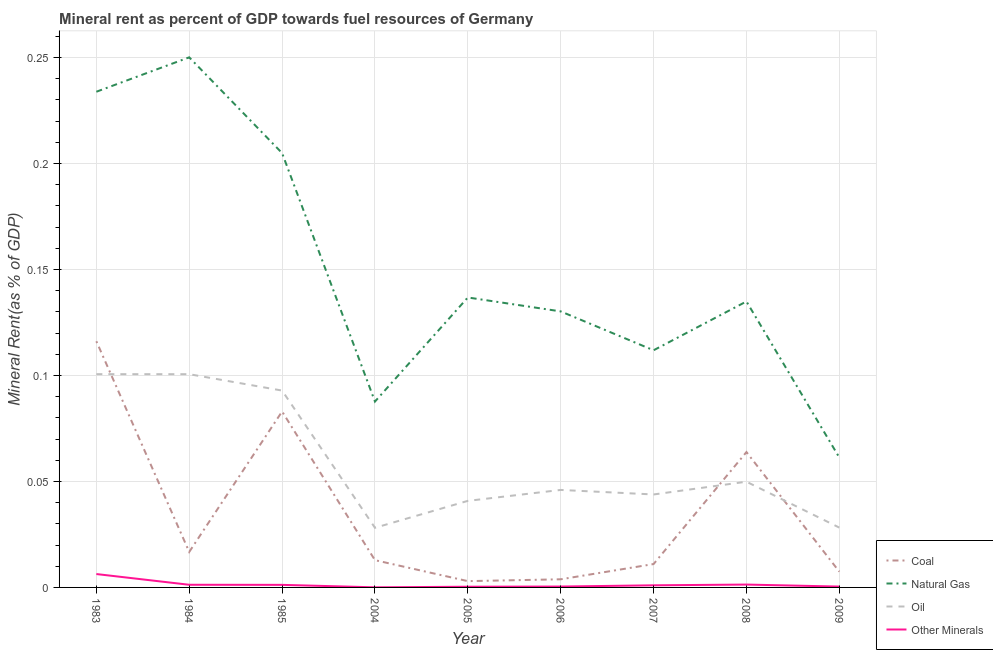Is the number of lines equal to the number of legend labels?
Your answer should be very brief. Yes. What is the oil rent in 1985?
Your response must be concise. 0.09. Across all years, what is the maximum coal rent?
Ensure brevity in your answer.  0.12. Across all years, what is the minimum coal rent?
Offer a terse response. 0. In which year was the oil rent minimum?
Make the answer very short. 2004. What is the total natural gas rent in the graph?
Provide a succinct answer. 1.35. What is the difference between the coal rent in 1985 and that in 2006?
Your answer should be compact. 0.08. What is the difference between the  rent of other minerals in 1985 and the natural gas rent in 2007?
Your response must be concise. -0.11. What is the average natural gas rent per year?
Give a very brief answer. 0.15. In the year 2006, what is the difference between the natural gas rent and oil rent?
Keep it short and to the point. 0.08. In how many years, is the  rent of other minerals greater than 0.24000000000000002 %?
Your answer should be very brief. 0. What is the ratio of the  rent of other minerals in 2008 to that in 2009?
Your answer should be very brief. 3.35. Is the difference between the oil rent in 1983 and 2008 greater than the difference between the  rent of other minerals in 1983 and 2008?
Give a very brief answer. Yes. What is the difference between the highest and the second highest coal rent?
Ensure brevity in your answer.  0.03. What is the difference between the highest and the lowest  rent of other minerals?
Your answer should be compact. 0.01. In how many years, is the oil rent greater than the average oil rent taken over all years?
Keep it short and to the point. 3. Is it the case that in every year, the sum of the coal rent and natural gas rent is greater than the oil rent?
Provide a succinct answer. Yes. Does the natural gas rent monotonically increase over the years?
Ensure brevity in your answer.  No. Is the  rent of other minerals strictly greater than the coal rent over the years?
Keep it short and to the point. No. Is the  rent of other minerals strictly less than the natural gas rent over the years?
Offer a terse response. Yes. How many lines are there?
Ensure brevity in your answer.  4. What is the difference between two consecutive major ticks on the Y-axis?
Offer a terse response. 0.05. Are the values on the major ticks of Y-axis written in scientific E-notation?
Offer a terse response. No. Does the graph contain any zero values?
Your response must be concise. No. Does the graph contain grids?
Ensure brevity in your answer.  Yes. How many legend labels are there?
Keep it short and to the point. 4. What is the title of the graph?
Keep it short and to the point. Mineral rent as percent of GDP towards fuel resources of Germany. Does "Public sector management" appear as one of the legend labels in the graph?
Offer a terse response. No. What is the label or title of the Y-axis?
Ensure brevity in your answer.  Mineral Rent(as % of GDP). What is the Mineral Rent(as % of GDP) in Coal in 1983?
Provide a succinct answer. 0.12. What is the Mineral Rent(as % of GDP) in Natural Gas in 1983?
Offer a very short reply. 0.23. What is the Mineral Rent(as % of GDP) of Oil in 1983?
Make the answer very short. 0.1. What is the Mineral Rent(as % of GDP) of Other Minerals in 1983?
Offer a very short reply. 0.01. What is the Mineral Rent(as % of GDP) of Coal in 1984?
Your response must be concise. 0.02. What is the Mineral Rent(as % of GDP) of Natural Gas in 1984?
Your answer should be very brief. 0.25. What is the Mineral Rent(as % of GDP) in Oil in 1984?
Offer a very short reply. 0.1. What is the Mineral Rent(as % of GDP) in Other Minerals in 1984?
Your answer should be very brief. 0. What is the Mineral Rent(as % of GDP) in Coal in 1985?
Keep it short and to the point. 0.08. What is the Mineral Rent(as % of GDP) in Natural Gas in 1985?
Give a very brief answer. 0.2. What is the Mineral Rent(as % of GDP) in Oil in 1985?
Provide a short and direct response. 0.09. What is the Mineral Rent(as % of GDP) in Other Minerals in 1985?
Your answer should be very brief. 0. What is the Mineral Rent(as % of GDP) of Coal in 2004?
Offer a terse response. 0.01. What is the Mineral Rent(as % of GDP) of Natural Gas in 2004?
Offer a terse response. 0.09. What is the Mineral Rent(as % of GDP) in Oil in 2004?
Give a very brief answer. 0.03. What is the Mineral Rent(as % of GDP) in Other Minerals in 2004?
Offer a terse response. 4.34617958129475e-5. What is the Mineral Rent(as % of GDP) in Coal in 2005?
Give a very brief answer. 0. What is the Mineral Rent(as % of GDP) of Natural Gas in 2005?
Your answer should be very brief. 0.14. What is the Mineral Rent(as % of GDP) of Oil in 2005?
Offer a very short reply. 0.04. What is the Mineral Rent(as % of GDP) of Other Minerals in 2005?
Provide a short and direct response. 0. What is the Mineral Rent(as % of GDP) of Coal in 2006?
Your response must be concise. 0. What is the Mineral Rent(as % of GDP) of Natural Gas in 2006?
Your response must be concise. 0.13. What is the Mineral Rent(as % of GDP) in Oil in 2006?
Offer a very short reply. 0.05. What is the Mineral Rent(as % of GDP) of Other Minerals in 2006?
Make the answer very short. 0. What is the Mineral Rent(as % of GDP) in Coal in 2007?
Keep it short and to the point. 0.01. What is the Mineral Rent(as % of GDP) in Natural Gas in 2007?
Your response must be concise. 0.11. What is the Mineral Rent(as % of GDP) in Oil in 2007?
Your response must be concise. 0.04. What is the Mineral Rent(as % of GDP) in Other Minerals in 2007?
Offer a terse response. 0. What is the Mineral Rent(as % of GDP) of Coal in 2008?
Provide a short and direct response. 0.06. What is the Mineral Rent(as % of GDP) of Natural Gas in 2008?
Your answer should be very brief. 0.13. What is the Mineral Rent(as % of GDP) in Oil in 2008?
Provide a short and direct response. 0.05. What is the Mineral Rent(as % of GDP) in Other Minerals in 2008?
Your answer should be very brief. 0. What is the Mineral Rent(as % of GDP) in Coal in 2009?
Ensure brevity in your answer.  0.01. What is the Mineral Rent(as % of GDP) in Natural Gas in 2009?
Your answer should be compact. 0.06. What is the Mineral Rent(as % of GDP) of Oil in 2009?
Your answer should be compact. 0.03. What is the Mineral Rent(as % of GDP) in Other Minerals in 2009?
Your response must be concise. 0. Across all years, what is the maximum Mineral Rent(as % of GDP) in Coal?
Your answer should be very brief. 0.12. Across all years, what is the maximum Mineral Rent(as % of GDP) in Natural Gas?
Your response must be concise. 0.25. Across all years, what is the maximum Mineral Rent(as % of GDP) of Oil?
Your response must be concise. 0.1. Across all years, what is the maximum Mineral Rent(as % of GDP) in Other Minerals?
Your answer should be compact. 0.01. Across all years, what is the minimum Mineral Rent(as % of GDP) in Coal?
Your response must be concise. 0. Across all years, what is the minimum Mineral Rent(as % of GDP) in Natural Gas?
Offer a terse response. 0.06. Across all years, what is the minimum Mineral Rent(as % of GDP) in Oil?
Your response must be concise. 0.03. Across all years, what is the minimum Mineral Rent(as % of GDP) of Other Minerals?
Your response must be concise. 4.34617958129475e-5. What is the total Mineral Rent(as % of GDP) of Coal in the graph?
Make the answer very short. 0.32. What is the total Mineral Rent(as % of GDP) of Natural Gas in the graph?
Provide a succinct answer. 1.35. What is the total Mineral Rent(as % of GDP) of Oil in the graph?
Your answer should be compact. 0.53. What is the total Mineral Rent(as % of GDP) of Other Minerals in the graph?
Give a very brief answer. 0.01. What is the difference between the Mineral Rent(as % of GDP) in Coal in 1983 and that in 1984?
Make the answer very short. 0.1. What is the difference between the Mineral Rent(as % of GDP) of Natural Gas in 1983 and that in 1984?
Offer a terse response. -0.02. What is the difference between the Mineral Rent(as % of GDP) of Oil in 1983 and that in 1984?
Keep it short and to the point. 0. What is the difference between the Mineral Rent(as % of GDP) of Other Minerals in 1983 and that in 1984?
Your response must be concise. 0.01. What is the difference between the Mineral Rent(as % of GDP) of Coal in 1983 and that in 1985?
Provide a succinct answer. 0.03. What is the difference between the Mineral Rent(as % of GDP) in Natural Gas in 1983 and that in 1985?
Keep it short and to the point. 0.03. What is the difference between the Mineral Rent(as % of GDP) in Oil in 1983 and that in 1985?
Ensure brevity in your answer.  0.01. What is the difference between the Mineral Rent(as % of GDP) of Other Minerals in 1983 and that in 1985?
Offer a very short reply. 0.01. What is the difference between the Mineral Rent(as % of GDP) in Coal in 1983 and that in 2004?
Your answer should be compact. 0.1. What is the difference between the Mineral Rent(as % of GDP) in Natural Gas in 1983 and that in 2004?
Your answer should be very brief. 0.15. What is the difference between the Mineral Rent(as % of GDP) of Oil in 1983 and that in 2004?
Give a very brief answer. 0.07. What is the difference between the Mineral Rent(as % of GDP) in Other Minerals in 1983 and that in 2004?
Keep it short and to the point. 0.01. What is the difference between the Mineral Rent(as % of GDP) in Coal in 1983 and that in 2005?
Provide a short and direct response. 0.11. What is the difference between the Mineral Rent(as % of GDP) of Natural Gas in 1983 and that in 2005?
Ensure brevity in your answer.  0.1. What is the difference between the Mineral Rent(as % of GDP) of Oil in 1983 and that in 2005?
Your response must be concise. 0.06. What is the difference between the Mineral Rent(as % of GDP) of Other Minerals in 1983 and that in 2005?
Provide a short and direct response. 0.01. What is the difference between the Mineral Rent(as % of GDP) of Coal in 1983 and that in 2006?
Keep it short and to the point. 0.11. What is the difference between the Mineral Rent(as % of GDP) in Natural Gas in 1983 and that in 2006?
Offer a very short reply. 0.1. What is the difference between the Mineral Rent(as % of GDP) of Oil in 1983 and that in 2006?
Offer a terse response. 0.05. What is the difference between the Mineral Rent(as % of GDP) of Other Minerals in 1983 and that in 2006?
Your answer should be very brief. 0.01. What is the difference between the Mineral Rent(as % of GDP) of Coal in 1983 and that in 2007?
Offer a very short reply. 0.11. What is the difference between the Mineral Rent(as % of GDP) in Natural Gas in 1983 and that in 2007?
Ensure brevity in your answer.  0.12. What is the difference between the Mineral Rent(as % of GDP) in Oil in 1983 and that in 2007?
Make the answer very short. 0.06. What is the difference between the Mineral Rent(as % of GDP) of Other Minerals in 1983 and that in 2007?
Give a very brief answer. 0.01. What is the difference between the Mineral Rent(as % of GDP) of Coal in 1983 and that in 2008?
Your response must be concise. 0.05. What is the difference between the Mineral Rent(as % of GDP) in Natural Gas in 1983 and that in 2008?
Make the answer very short. 0.1. What is the difference between the Mineral Rent(as % of GDP) of Oil in 1983 and that in 2008?
Offer a terse response. 0.05. What is the difference between the Mineral Rent(as % of GDP) of Other Minerals in 1983 and that in 2008?
Your answer should be compact. 0.01. What is the difference between the Mineral Rent(as % of GDP) in Coal in 1983 and that in 2009?
Your answer should be very brief. 0.11. What is the difference between the Mineral Rent(as % of GDP) of Natural Gas in 1983 and that in 2009?
Provide a short and direct response. 0.17. What is the difference between the Mineral Rent(as % of GDP) of Oil in 1983 and that in 2009?
Provide a short and direct response. 0.07. What is the difference between the Mineral Rent(as % of GDP) of Other Minerals in 1983 and that in 2009?
Offer a very short reply. 0.01. What is the difference between the Mineral Rent(as % of GDP) of Coal in 1984 and that in 1985?
Your answer should be very brief. -0.07. What is the difference between the Mineral Rent(as % of GDP) in Natural Gas in 1984 and that in 1985?
Offer a very short reply. 0.05. What is the difference between the Mineral Rent(as % of GDP) in Oil in 1984 and that in 1985?
Keep it short and to the point. 0.01. What is the difference between the Mineral Rent(as % of GDP) in Coal in 1984 and that in 2004?
Your answer should be very brief. 0. What is the difference between the Mineral Rent(as % of GDP) of Natural Gas in 1984 and that in 2004?
Your response must be concise. 0.16. What is the difference between the Mineral Rent(as % of GDP) of Oil in 1984 and that in 2004?
Make the answer very short. 0.07. What is the difference between the Mineral Rent(as % of GDP) in Other Minerals in 1984 and that in 2004?
Give a very brief answer. 0. What is the difference between the Mineral Rent(as % of GDP) of Coal in 1984 and that in 2005?
Your answer should be very brief. 0.01. What is the difference between the Mineral Rent(as % of GDP) in Natural Gas in 1984 and that in 2005?
Your answer should be compact. 0.11. What is the difference between the Mineral Rent(as % of GDP) in Oil in 1984 and that in 2005?
Provide a succinct answer. 0.06. What is the difference between the Mineral Rent(as % of GDP) of Other Minerals in 1984 and that in 2005?
Your answer should be compact. 0. What is the difference between the Mineral Rent(as % of GDP) in Coal in 1984 and that in 2006?
Ensure brevity in your answer.  0.01. What is the difference between the Mineral Rent(as % of GDP) in Natural Gas in 1984 and that in 2006?
Give a very brief answer. 0.12. What is the difference between the Mineral Rent(as % of GDP) in Oil in 1984 and that in 2006?
Your answer should be compact. 0.05. What is the difference between the Mineral Rent(as % of GDP) in Other Minerals in 1984 and that in 2006?
Your response must be concise. 0. What is the difference between the Mineral Rent(as % of GDP) in Coal in 1984 and that in 2007?
Keep it short and to the point. 0.01. What is the difference between the Mineral Rent(as % of GDP) of Natural Gas in 1984 and that in 2007?
Provide a succinct answer. 0.14. What is the difference between the Mineral Rent(as % of GDP) of Oil in 1984 and that in 2007?
Offer a terse response. 0.06. What is the difference between the Mineral Rent(as % of GDP) of Coal in 1984 and that in 2008?
Provide a succinct answer. -0.05. What is the difference between the Mineral Rent(as % of GDP) in Natural Gas in 1984 and that in 2008?
Offer a very short reply. 0.12. What is the difference between the Mineral Rent(as % of GDP) in Oil in 1984 and that in 2008?
Keep it short and to the point. 0.05. What is the difference between the Mineral Rent(as % of GDP) in Other Minerals in 1984 and that in 2008?
Provide a succinct answer. -0. What is the difference between the Mineral Rent(as % of GDP) in Coal in 1984 and that in 2009?
Give a very brief answer. 0.01. What is the difference between the Mineral Rent(as % of GDP) of Natural Gas in 1984 and that in 2009?
Your answer should be very brief. 0.19. What is the difference between the Mineral Rent(as % of GDP) in Oil in 1984 and that in 2009?
Ensure brevity in your answer.  0.07. What is the difference between the Mineral Rent(as % of GDP) of Other Minerals in 1984 and that in 2009?
Ensure brevity in your answer.  0. What is the difference between the Mineral Rent(as % of GDP) in Coal in 1985 and that in 2004?
Ensure brevity in your answer.  0.07. What is the difference between the Mineral Rent(as % of GDP) in Natural Gas in 1985 and that in 2004?
Keep it short and to the point. 0.12. What is the difference between the Mineral Rent(as % of GDP) of Oil in 1985 and that in 2004?
Provide a succinct answer. 0.06. What is the difference between the Mineral Rent(as % of GDP) of Other Minerals in 1985 and that in 2004?
Offer a very short reply. 0. What is the difference between the Mineral Rent(as % of GDP) of Natural Gas in 1985 and that in 2005?
Give a very brief answer. 0.07. What is the difference between the Mineral Rent(as % of GDP) in Oil in 1985 and that in 2005?
Keep it short and to the point. 0.05. What is the difference between the Mineral Rent(as % of GDP) of Other Minerals in 1985 and that in 2005?
Give a very brief answer. 0. What is the difference between the Mineral Rent(as % of GDP) in Coal in 1985 and that in 2006?
Provide a succinct answer. 0.08. What is the difference between the Mineral Rent(as % of GDP) in Natural Gas in 1985 and that in 2006?
Provide a succinct answer. 0.07. What is the difference between the Mineral Rent(as % of GDP) of Oil in 1985 and that in 2006?
Keep it short and to the point. 0.05. What is the difference between the Mineral Rent(as % of GDP) in Other Minerals in 1985 and that in 2006?
Your answer should be compact. 0. What is the difference between the Mineral Rent(as % of GDP) of Coal in 1985 and that in 2007?
Ensure brevity in your answer.  0.07. What is the difference between the Mineral Rent(as % of GDP) in Natural Gas in 1985 and that in 2007?
Provide a short and direct response. 0.09. What is the difference between the Mineral Rent(as % of GDP) in Oil in 1985 and that in 2007?
Ensure brevity in your answer.  0.05. What is the difference between the Mineral Rent(as % of GDP) in Other Minerals in 1985 and that in 2007?
Provide a succinct answer. 0. What is the difference between the Mineral Rent(as % of GDP) in Coal in 1985 and that in 2008?
Your answer should be compact. 0.02. What is the difference between the Mineral Rent(as % of GDP) of Natural Gas in 1985 and that in 2008?
Your answer should be compact. 0.07. What is the difference between the Mineral Rent(as % of GDP) in Oil in 1985 and that in 2008?
Provide a succinct answer. 0.04. What is the difference between the Mineral Rent(as % of GDP) in Other Minerals in 1985 and that in 2008?
Ensure brevity in your answer.  -0. What is the difference between the Mineral Rent(as % of GDP) in Coal in 1985 and that in 2009?
Make the answer very short. 0.08. What is the difference between the Mineral Rent(as % of GDP) in Natural Gas in 1985 and that in 2009?
Your answer should be very brief. 0.14. What is the difference between the Mineral Rent(as % of GDP) in Oil in 1985 and that in 2009?
Provide a short and direct response. 0.06. What is the difference between the Mineral Rent(as % of GDP) of Other Minerals in 1985 and that in 2009?
Your answer should be compact. 0. What is the difference between the Mineral Rent(as % of GDP) of Coal in 2004 and that in 2005?
Provide a succinct answer. 0.01. What is the difference between the Mineral Rent(as % of GDP) of Natural Gas in 2004 and that in 2005?
Keep it short and to the point. -0.05. What is the difference between the Mineral Rent(as % of GDP) in Oil in 2004 and that in 2005?
Offer a terse response. -0.01. What is the difference between the Mineral Rent(as % of GDP) of Other Minerals in 2004 and that in 2005?
Give a very brief answer. -0. What is the difference between the Mineral Rent(as % of GDP) of Coal in 2004 and that in 2006?
Provide a short and direct response. 0.01. What is the difference between the Mineral Rent(as % of GDP) in Natural Gas in 2004 and that in 2006?
Your response must be concise. -0.04. What is the difference between the Mineral Rent(as % of GDP) of Oil in 2004 and that in 2006?
Give a very brief answer. -0.02. What is the difference between the Mineral Rent(as % of GDP) in Other Minerals in 2004 and that in 2006?
Give a very brief answer. -0. What is the difference between the Mineral Rent(as % of GDP) in Coal in 2004 and that in 2007?
Keep it short and to the point. 0. What is the difference between the Mineral Rent(as % of GDP) of Natural Gas in 2004 and that in 2007?
Make the answer very short. -0.02. What is the difference between the Mineral Rent(as % of GDP) in Oil in 2004 and that in 2007?
Your answer should be very brief. -0.02. What is the difference between the Mineral Rent(as % of GDP) of Other Minerals in 2004 and that in 2007?
Offer a terse response. -0. What is the difference between the Mineral Rent(as % of GDP) of Coal in 2004 and that in 2008?
Provide a short and direct response. -0.05. What is the difference between the Mineral Rent(as % of GDP) of Natural Gas in 2004 and that in 2008?
Offer a very short reply. -0.05. What is the difference between the Mineral Rent(as % of GDP) in Oil in 2004 and that in 2008?
Your response must be concise. -0.02. What is the difference between the Mineral Rent(as % of GDP) in Other Minerals in 2004 and that in 2008?
Ensure brevity in your answer.  -0. What is the difference between the Mineral Rent(as % of GDP) of Coal in 2004 and that in 2009?
Ensure brevity in your answer.  0.01. What is the difference between the Mineral Rent(as % of GDP) of Natural Gas in 2004 and that in 2009?
Ensure brevity in your answer.  0.03. What is the difference between the Mineral Rent(as % of GDP) in Oil in 2004 and that in 2009?
Keep it short and to the point. -0. What is the difference between the Mineral Rent(as % of GDP) in Other Minerals in 2004 and that in 2009?
Make the answer very short. -0. What is the difference between the Mineral Rent(as % of GDP) of Coal in 2005 and that in 2006?
Provide a short and direct response. -0. What is the difference between the Mineral Rent(as % of GDP) in Natural Gas in 2005 and that in 2006?
Your response must be concise. 0.01. What is the difference between the Mineral Rent(as % of GDP) of Oil in 2005 and that in 2006?
Provide a succinct answer. -0.01. What is the difference between the Mineral Rent(as % of GDP) of Other Minerals in 2005 and that in 2006?
Your answer should be very brief. -0. What is the difference between the Mineral Rent(as % of GDP) of Coal in 2005 and that in 2007?
Your response must be concise. -0.01. What is the difference between the Mineral Rent(as % of GDP) in Natural Gas in 2005 and that in 2007?
Keep it short and to the point. 0.02. What is the difference between the Mineral Rent(as % of GDP) in Oil in 2005 and that in 2007?
Your answer should be compact. -0. What is the difference between the Mineral Rent(as % of GDP) of Other Minerals in 2005 and that in 2007?
Your response must be concise. -0. What is the difference between the Mineral Rent(as % of GDP) in Coal in 2005 and that in 2008?
Make the answer very short. -0.06. What is the difference between the Mineral Rent(as % of GDP) of Natural Gas in 2005 and that in 2008?
Offer a very short reply. 0. What is the difference between the Mineral Rent(as % of GDP) in Oil in 2005 and that in 2008?
Provide a short and direct response. -0.01. What is the difference between the Mineral Rent(as % of GDP) in Other Minerals in 2005 and that in 2008?
Your answer should be very brief. -0. What is the difference between the Mineral Rent(as % of GDP) in Coal in 2005 and that in 2009?
Your response must be concise. -0. What is the difference between the Mineral Rent(as % of GDP) in Natural Gas in 2005 and that in 2009?
Make the answer very short. 0.08. What is the difference between the Mineral Rent(as % of GDP) of Oil in 2005 and that in 2009?
Ensure brevity in your answer.  0.01. What is the difference between the Mineral Rent(as % of GDP) in Other Minerals in 2005 and that in 2009?
Offer a terse response. -0. What is the difference between the Mineral Rent(as % of GDP) of Coal in 2006 and that in 2007?
Offer a very short reply. -0.01. What is the difference between the Mineral Rent(as % of GDP) of Natural Gas in 2006 and that in 2007?
Provide a succinct answer. 0.02. What is the difference between the Mineral Rent(as % of GDP) of Oil in 2006 and that in 2007?
Offer a terse response. 0. What is the difference between the Mineral Rent(as % of GDP) of Other Minerals in 2006 and that in 2007?
Make the answer very short. -0. What is the difference between the Mineral Rent(as % of GDP) in Coal in 2006 and that in 2008?
Your response must be concise. -0.06. What is the difference between the Mineral Rent(as % of GDP) of Natural Gas in 2006 and that in 2008?
Provide a succinct answer. -0. What is the difference between the Mineral Rent(as % of GDP) in Oil in 2006 and that in 2008?
Your answer should be very brief. -0. What is the difference between the Mineral Rent(as % of GDP) of Other Minerals in 2006 and that in 2008?
Your answer should be very brief. -0. What is the difference between the Mineral Rent(as % of GDP) of Coal in 2006 and that in 2009?
Provide a short and direct response. -0. What is the difference between the Mineral Rent(as % of GDP) of Natural Gas in 2006 and that in 2009?
Offer a terse response. 0.07. What is the difference between the Mineral Rent(as % of GDP) in Oil in 2006 and that in 2009?
Offer a terse response. 0.02. What is the difference between the Mineral Rent(as % of GDP) of Coal in 2007 and that in 2008?
Offer a very short reply. -0.05. What is the difference between the Mineral Rent(as % of GDP) of Natural Gas in 2007 and that in 2008?
Offer a terse response. -0.02. What is the difference between the Mineral Rent(as % of GDP) of Oil in 2007 and that in 2008?
Your answer should be compact. -0.01. What is the difference between the Mineral Rent(as % of GDP) in Other Minerals in 2007 and that in 2008?
Ensure brevity in your answer.  -0. What is the difference between the Mineral Rent(as % of GDP) in Coal in 2007 and that in 2009?
Provide a succinct answer. 0. What is the difference between the Mineral Rent(as % of GDP) in Natural Gas in 2007 and that in 2009?
Ensure brevity in your answer.  0.05. What is the difference between the Mineral Rent(as % of GDP) of Oil in 2007 and that in 2009?
Your answer should be compact. 0.02. What is the difference between the Mineral Rent(as % of GDP) of Other Minerals in 2007 and that in 2009?
Offer a very short reply. 0. What is the difference between the Mineral Rent(as % of GDP) in Coal in 2008 and that in 2009?
Offer a very short reply. 0.06. What is the difference between the Mineral Rent(as % of GDP) in Natural Gas in 2008 and that in 2009?
Provide a short and direct response. 0.07. What is the difference between the Mineral Rent(as % of GDP) in Oil in 2008 and that in 2009?
Offer a terse response. 0.02. What is the difference between the Mineral Rent(as % of GDP) of Other Minerals in 2008 and that in 2009?
Offer a very short reply. 0. What is the difference between the Mineral Rent(as % of GDP) in Coal in 1983 and the Mineral Rent(as % of GDP) in Natural Gas in 1984?
Provide a succinct answer. -0.13. What is the difference between the Mineral Rent(as % of GDP) in Coal in 1983 and the Mineral Rent(as % of GDP) in Oil in 1984?
Offer a terse response. 0.02. What is the difference between the Mineral Rent(as % of GDP) of Coal in 1983 and the Mineral Rent(as % of GDP) of Other Minerals in 1984?
Ensure brevity in your answer.  0.11. What is the difference between the Mineral Rent(as % of GDP) in Natural Gas in 1983 and the Mineral Rent(as % of GDP) in Oil in 1984?
Your answer should be compact. 0.13. What is the difference between the Mineral Rent(as % of GDP) in Natural Gas in 1983 and the Mineral Rent(as % of GDP) in Other Minerals in 1984?
Make the answer very short. 0.23. What is the difference between the Mineral Rent(as % of GDP) in Oil in 1983 and the Mineral Rent(as % of GDP) in Other Minerals in 1984?
Offer a terse response. 0.1. What is the difference between the Mineral Rent(as % of GDP) of Coal in 1983 and the Mineral Rent(as % of GDP) of Natural Gas in 1985?
Your response must be concise. -0.09. What is the difference between the Mineral Rent(as % of GDP) of Coal in 1983 and the Mineral Rent(as % of GDP) of Oil in 1985?
Your answer should be compact. 0.02. What is the difference between the Mineral Rent(as % of GDP) of Coal in 1983 and the Mineral Rent(as % of GDP) of Other Minerals in 1985?
Keep it short and to the point. 0.11. What is the difference between the Mineral Rent(as % of GDP) in Natural Gas in 1983 and the Mineral Rent(as % of GDP) in Oil in 1985?
Offer a terse response. 0.14. What is the difference between the Mineral Rent(as % of GDP) of Natural Gas in 1983 and the Mineral Rent(as % of GDP) of Other Minerals in 1985?
Make the answer very short. 0.23. What is the difference between the Mineral Rent(as % of GDP) in Oil in 1983 and the Mineral Rent(as % of GDP) in Other Minerals in 1985?
Ensure brevity in your answer.  0.1. What is the difference between the Mineral Rent(as % of GDP) in Coal in 1983 and the Mineral Rent(as % of GDP) in Natural Gas in 2004?
Offer a very short reply. 0.03. What is the difference between the Mineral Rent(as % of GDP) in Coal in 1983 and the Mineral Rent(as % of GDP) in Oil in 2004?
Give a very brief answer. 0.09. What is the difference between the Mineral Rent(as % of GDP) of Coal in 1983 and the Mineral Rent(as % of GDP) of Other Minerals in 2004?
Your answer should be very brief. 0.12. What is the difference between the Mineral Rent(as % of GDP) in Natural Gas in 1983 and the Mineral Rent(as % of GDP) in Oil in 2004?
Offer a terse response. 0.21. What is the difference between the Mineral Rent(as % of GDP) in Natural Gas in 1983 and the Mineral Rent(as % of GDP) in Other Minerals in 2004?
Make the answer very short. 0.23. What is the difference between the Mineral Rent(as % of GDP) of Oil in 1983 and the Mineral Rent(as % of GDP) of Other Minerals in 2004?
Your response must be concise. 0.1. What is the difference between the Mineral Rent(as % of GDP) of Coal in 1983 and the Mineral Rent(as % of GDP) of Natural Gas in 2005?
Offer a very short reply. -0.02. What is the difference between the Mineral Rent(as % of GDP) of Coal in 1983 and the Mineral Rent(as % of GDP) of Oil in 2005?
Your response must be concise. 0.08. What is the difference between the Mineral Rent(as % of GDP) of Coal in 1983 and the Mineral Rent(as % of GDP) of Other Minerals in 2005?
Make the answer very short. 0.12. What is the difference between the Mineral Rent(as % of GDP) of Natural Gas in 1983 and the Mineral Rent(as % of GDP) of Oil in 2005?
Provide a short and direct response. 0.19. What is the difference between the Mineral Rent(as % of GDP) in Natural Gas in 1983 and the Mineral Rent(as % of GDP) in Other Minerals in 2005?
Give a very brief answer. 0.23. What is the difference between the Mineral Rent(as % of GDP) in Oil in 1983 and the Mineral Rent(as % of GDP) in Other Minerals in 2005?
Your answer should be very brief. 0.1. What is the difference between the Mineral Rent(as % of GDP) in Coal in 1983 and the Mineral Rent(as % of GDP) in Natural Gas in 2006?
Give a very brief answer. -0.01. What is the difference between the Mineral Rent(as % of GDP) in Coal in 1983 and the Mineral Rent(as % of GDP) in Oil in 2006?
Make the answer very short. 0.07. What is the difference between the Mineral Rent(as % of GDP) in Coal in 1983 and the Mineral Rent(as % of GDP) in Other Minerals in 2006?
Ensure brevity in your answer.  0.12. What is the difference between the Mineral Rent(as % of GDP) of Natural Gas in 1983 and the Mineral Rent(as % of GDP) of Oil in 2006?
Your response must be concise. 0.19. What is the difference between the Mineral Rent(as % of GDP) of Natural Gas in 1983 and the Mineral Rent(as % of GDP) of Other Minerals in 2006?
Provide a succinct answer. 0.23. What is the difference between the Mineral Rent(as % of GDP) of Oil in 1983 and the Mineral Rent(as % of GDP) of Other Minerals in 2006?
Provide a short and direct response. 0.1. What is the difference between the Mineral Rent(as % of GDP) in Coal in 1983 and the Mineral Rent(as % of GDP) in Natural Gas in 2007?
Ensure brevity in your answer.  0. What is the difference between the Mineral Rent(as % of GDP) in Coal in 1983 and the Mineral Rent(as % of GDP) in Oil in 2007?
Give a very brief answer. 0.07. What is the difference between the Mineral Rent(as % of GDP) in Coal in 1983 and the Mineral Rent(as % of GDP) in Other Minerals in 2007?
Your answer should be very brief. 0.12. What is the difference between the Mineral Rent(as % of GDP) of Natural Gas in 1983 and the Mineral Rent(as % of GDP) of Oil in 2007?
Your answer should be compact. 0.19. What is the difference between the Mineral Rent(as % of GDP) in Natural Gas in 1983 and the Mineral Rent(as % of GDP) in Other Minerals in 2007?
Give a very brief answer. 0.23. What is the difference between the Mineral Rent(as % of GDP) in Oil in 1983 and the Mineral Rent(as % of GDP) in Other Minerals in 2007?
Ensure brevity in your answer.  0.1. What is the difference between the Mineral Rent(as % of GDP) in Coal in 1983 and the Mineral Rent(as % of GDP) in Natural Gas in 2008?
Give a very brief answer. -0.02. What is the difference between the Mineral Rent(as % of GDP) of Coal in 1983 and the Mineral Rent(as % of GDP) of Oil in 2008?
Give a very brief answer. 0.07. What is the difference between the Mineral Rent(as % of GDP) in Coal in 1983 and the Mineral Rent(as % of GDP) in Other Minerals in 2008?
Provide a succinct answer. 0.11. What is the difference between the Mineral Rent(as % of GDP) in Natural Gas in 1983 and the Mineral Rent(as % of GDP) in Oil in 2008?
Your answer should be very brief. 0.18. What is the difference between the Mineral Rent(as % of GDP) of Natural Gas in 1983 and the Mineral Rent(as % of GDP) of Other Minerals in 2008?
Offer a very short reply. 0.23. What is the difference between the Mineral Rent(as % of GDP) of Oil in 1983 and the Mineral Rent(as % of GDP) of Other Minerals in 2008?
Ensure brevity in your answer.  0.1. What is the difference between the Mineral Rent(as % of GDP) of Coal in 1983 and the Mineral Rent(as % of GDP) of Natural Gas in 2009?
Ensure brevity in your answer.  0.05. What is the difference between the Mineral Rent(as % of GDP) in Coal in 1983 and the Mineral Rent(as % of GDP) in Oil in 2009?
Give a very brief answer. 0.09. What is the difference between the Mineral Rent(as % of GDP) in Coal in 1983 and the Mineral Rent(as % of GDP) in Other Minerals in 2009?
Provide a short and direct response. 0.12. What is the difference between the Mineral Rent(as % of GDP) of Natural Gas in 1983 and the Mineral Rent(as % of GDP) of Oil in 2009?
Make the answer very short. 0.21. What is the difference between the Mineral Rent(as % of GDP) in Natural Gas in 1983 and the Mineral Rent(as % of GDP) in Other Minerals in 2009?
Your response must be concise. 0.23. What is the difference between the Mineral Rent(as % of GDP) in Oil in 1983 and the Mineral Rent(as % of GDP) in Other Minerals in 2009?
Your answer should be compact. 0.1. What is the difference between the Mineral Rent(as % of GDP) of Coal in 1984 and the Mineral Rent(as % of GDP) of Natural Gas in 1985?
Keep it short and to the point. -0.19. What is the difference between the Mineral Rent(as % of GDP) in Coal in 1984 and the Mineral Rent(as % of GDP) in Oil in 1985?
Keep it short and to the point. -0.08. What is the difference between the Mineral Rent(as % of GDP) of Coal in 1984 and the Mineral Rent(as % of GDP) of Other Minerals in 1985?
Offer a very short reply. 0.02. What is the difference between the Mineral Rent(as % of GDP) of Natural Gas in 1984 and the Mineral Rent(as % of GDP) of Oil in 1985?
Provide a succinct answer. 0.16. What is the difference between the Mineral Rent(as % of GDP) of Natural Gas in 1984 and the Mineral Rent(as % of GDP) of Other Minerals in 1985?
Offer a terse response. 0.25. What is the difference between the Mineral Rent(as % of GDP) of Oil in 1984 and the Mineral Rent(as % of GDP) of Other Minerals in 1985?
Ensure brevity in your answer.  0.1. What is the difference between the Mineral Rent(as % of GDP) in Coal in 1984 and the Mineral Rent(as % of GDP) in Natural Gas in 2004?
Give a very brief answer. -0.07. What is the difference between the Mineral Rent(as % of GDP) in Coal in 1984 and the Mineral Rent(as % of GDP) in Oil in 2004?
Ensure brevity in your answer.  -0.01. What is the difference between the Mineral Rent(as % of GDP) in Coal in 1984 and the Mineral Rent(as % of GDP) in Other Minerals in 2004?
Your answer should be compact. 0.02. What is the difference between the Mineral Rent(as % of GDP) in Natural Gas in 1984 and the Mineral Rent(as % of GDP) in Oil in 2004?
Your answer should be very brief. 0.22. What is the difference between the Mineral Rent(as % of GDP) of Oil in 1984 and the Mineral Rent(as % of GDP) of Other Minerals in 2004?
Provide a succinct answer. 0.1. What is the difference between the Mineral Rent(as % of GDP) of Coal in 1984 and the Mineral Rent(as % of GDP) of Natural Gas in 2005?
Provide a succinct answer. -0.12. What is the difference between the Mineral Rent(as % of GDP) of Coal in 1984 and the Mineral Rent(as % of GDP) of Oil in 2005?
Offer a terse response. -0.02. What is the difference between the Mineral Rent(as % of GDP) in Coal in 1984 and the Mineral Rent(as % of GDP) in Other Minerals in 2005?
Provide a succinct answer. 0.02. What is the difference between the Mineral Rent(as % of GDP) in Natural Gas in 1984 and the Mineral Rent(as % of GDP) in Oil in 2005?
Ensure brevity in your answer.  0.21. What is the difference between the Mineral Rent(as % of GDP) in Natural Gas in 1984 and the Mineral Rent(as % of GDP) in Other Minerals in 2005?
Your answer should be very brief. 0.25. What is the difference between the Mineral Rent(as % of GDP) in Oil in 1984 and the Mineral Rent(as % of GDP) in Other Minerals in 2005?
Provide a short and direct response. 0.1. What is the difference between the Mineral Rent(as % of GDP) in Coal in 1984 and the Mineral Rent(as % of GDP) in Natural Gas in 2006?
Offer a very short reply. -0.11. What is the difference between the Mineral Rent(as % of GDP) in Coal in 1984 and the Mineral Rent(as % of GDP) in Oil in 2006?
Give a very brief answer. -0.03. What is the difference between the Mineral Rent(as % of GDP) of Coal in 1984 and the Mineral Rent(as % of GDP) of Other Minerals in 2006?
Ensure brevity in your answer.  0.02. What is the difference between the Mineral Rent(as % of GDP) of Natural Gas in 1984 and the Mineral Rent(as % of GDP) of Oil in 2006?
Your answer should be compact. 0.2. What is the difference between the Mineral Rent(as % of GDP) of Natural Gas in 1984 and the Mineral Rent(as % of GDP) of Other Minerals in 2006?
Your answer should be very brief. 0.25. What is the difference between the Mineral Rent(as % of GDP) of Oil in 1984 and the Mineral Rent(as % of GDP) of Other Minerals in 2006?
Keep it short and to the point. 0.1. What is the difference between the Mineral Rent(as % of GDP) of Coal in 1984 and the Mineral Rent(as % of GDP) of Natural Gas in 2007?
Your answer should be very brief. -0.1. What is the difference between the Mineral Rent(as % of GDP) in Coal in 1984 and the Mineral Rent(as % of GDP) in Oil in 2007?
Offer a very short reply. -0.03. What is the difference between the Mineral Rent(as % of GDP) of Coal in 1984 and the Mineral Rent(as % of GDP) of Other Minerals in 2007?
Give a very brief answer. 0.02. What is the difference between the Mineral Rent(as % of GDP) in Natural Gas in 1984 and the Mineral Rent(as % of GDP) in Oil in 2007?
Your answer should be compact. 0.21. What is the difference between the Mineral Rent(as % of GDP) in Natural Gas in 1984 and the Mineral Rent(as % of GDP) in Other Minerals in 2007?
Make the answer very short. 0.25. What is the difference between the Mineral Rent(as % of GDP) in Oil in 1984 and the Mineral Rent(as % of GDP) in Other Minerals in 2007?
Provide a short and direct response. 0.1. What is the difference between the Mineral Rent(as % of GDP) in Coal in 1984 and the Mineral Rent(as % of GDP) in Natural Gas in 2008?
Your response must be concise. -0.12. What is the difference between the Mineral Rent(as % of GDP) in Coal in 1984 and the Mineral Rent(as % of GDP) in Oil in 2008?
Your answer should be compact. -0.03. What is the difference between the Mineral Rent(as % of GDP) in Coal in 1984 and the Mineral Rent(as % of GDP) in Other Minerals in 2008?
Provide a short and direct response. 0.02. What is the difference between the Mineral Rent(as % of GDP) in Natural Gas in 1984 and the Mineral Rent(as % of GDP) in Oil in 2008?
Offer a terse response. 0.2. What is the difference between the Mineral Rent(as % of GDP) in Natural Gas in 1984 and the Mineral Rent(as % of GDP) in Other Minerals in 2008?
Keep it short and to the point. 0.25. What is the difference between the Mineral Rent(as % of GDP) of Oil in 1984 and the Mineral Rent(as % of GDP) of Other Minerals in 2008?
Your answer should be very brief. 0.1. What is the difference between the Mineral Rent(as % of GDP) of Coal in 1984 and the Mineral Rent(as % of GDP) of Natural Gas in 2009?
Offer a terse response. -0.04. What is the difference between the Mineral Rent(as % of GDP) in Coal in 1984 and the Mineral Rent(as % of GDP) in Oil in 2009?
Make the answer very short. -0.01. What is the difference between the Mineral Rent(as % of GDP) of Coal in 1984 and the Mineral Rent(as % of GDP) of Other Minerals in 2009?
Your answer should be compact. 0.02. What is the difference between the Mineral Rent(as % of GDP) in Natural Gas in 1984 and the Mineral Rent(as % of GDP) in Oil in 2009?
Provide a succinct answer. 0.22. What is the difference between the Mineral Rent(as % of GDP) in Natural Gas in 1984 and the Mineral Rent(as % of GDP) in Other Minerals in 2009?
Make the answer very short. 0.25. What is the difference between the Mineral Rent(as % of GDP) of Oil in 1984 and the Mineral Rent(as % of GDP) of Other Minerals in 2009?
Make the answer very short. 0.1. What is the difference between the Mineral Rent(as % of GDP) in Coal in 1985 and the Mineral Rent(as % of GDP) in Natural Gas in 2004?
Offer a terse response. -0. What is the difference between the Mineral Rent(as % of GDP) in Coal in 1985 and the Mineral Rent(as % of GDP) in Oil in 2004?
Ensure brevity in your answer.  0.05. What is the difference between the Mineral Rent(as % of GDP) in Coal in 1985 and the Mineral Rent(as % of GDP) in Other Minerals in 2004?
Offer a very short reply. 0.08. What is the difference between the Mineral Rent(as % of GDP) in Natural Gas in 1985 and the Mineral Rent(as % of GDP) in Oil in 2004?
Your answer should be very brief. 0.18. What is the difference between the Mineral Rent(as % of GDP) in Natural Gas in 1985 and the Mineral Rent(as % of GDP) in Other Minerals in 2004?
Your response must be concise. 0.2. What is the difference between the Mineral Rent(as % of GDP) in Oil in 1985 and the Mineral Rent(as % of GDP) in Other Minerals in 2004?
Your answer should be very brief. 0.09. What is the difference between the Mineral Rent(as % of GDP) of Coal in 1985 and the Mineral Rent(as % of GDP) of Natural Gas in 2005?
Provide a short and direct response. -0.05. What is the difference between the Mineral Rent(as % of GDP) in Coal in 1985 and the Mineral Rent(as % of GDP) in Oil in 2005?
Your answer should be very brief. 0.04. What is the difference between the Mineral Rent(as % of GDP) of Coal in 1985 and the Mineral Rent(as % of GDP) of Other Minerals in 2005?
Make the answer very short. 0.08. What is the difference between the Mineral Rent(as % of GDP) of Natural Gas in 1985 and the Mineral Rent(as % of GDP) of Oil in 2005?
Offer a very short reply. 0.16. What is the difference between the Mineral Rent(as % of GDP) of Natural Gas in 1985 and the Mineral Rent(as % of GDP) of Other Minerals in 2005?
Give a very brief answer. 0.2. What is the difference between the Mineral Rent(as % of GDP) in Oil in 1985 and the Mineral Rent(as % of GDP) in Other Minerals in 2005?
Ensure brevity in your answer.  0.09. What is the difference between the Mineral Rent(as % of GDP) of Coal in 1985 and the Mineral Rent(as % of GDP) of Natural Gas in 2006?
Provide a short and direct response. -0.05. What is the difference between the Mineral Rent(as % of GDP) of Coal in 1985 and the Mineral Rent(as % of GDP) of Oil in 2006?
Give a very brief answer. 0.04. What is the difference between the Mineral Rent(as % of GDP) of Coal in 1985 and the Mineral Rent(as % of GDP) of Other Minerals in 2006?
Offer a terse response. 0.08. What is the difference between the Mineral Rent(as % of GDP) in Natural Gas in 1985 and the Mineral Rent(as % of GDP) in Oil in 2006?
Your answer should be compact. 0.16. What is the difference between the Mineral Rent(as % of GDP) in Natural Gas in 1985 and the Mineral Rent(as % of GDP) in Other Minerals in 2006?
Make the answer very short. 0.2. What is the difference between the Mineral Rent(as % of GDP) in Oil in 1985 and the Mineral Rent(as % of GDP) in Other Minerals in 2006?
Your response must be concise. 0.09. What is the difference between the Mineral Rent(as % of GDP) in Coal in 1985 and the Mineral Rent(as % of GDP) in Natural Gas in 2007?
Make the answer very short. -0.03. What is the difference between the Mineral Rent(as % of GDP) of Coal in 1985 and the Mineral Rent(as % of GDP) of Oil in 2007?
Offer a terse response. 0.04. What is the difference between the Mineral Rent(as % of GDP) of Coal in 1985 and the Mineral Rent(as % of GDP) of Other Minerals in 2007?
Your answer should be compact. 0.08. What is the difference between the Mineral Rent(as % of GDP) of Natural Gas in 1985 and the Mineral Rent(as % of GDP) of Oil in 2007?
Provide a succinct answer. 0.16. What is the difference between the Mineral Rent(as % of GDP) of Natural Gas in 1985 and the Mineral Rent(as % of GDP) of Other Minerals in 2007?
Provide a succinct answer. 0.2. What is the difference between the Mineral Rent(as % of GDP) of Oil in 1985 and the Mineral Rent(as % of GDP) of Other Minerals in 2007?
Offer a terse response. 0.09. What is the difference between the Mineral Rent(as % of GDP) of Coal in 1985 and the Mineral Rent(as % of GDP) of Natural Gas in 2008?
Give a very brief answer. -0.05. What is the difference between the Mineral Rent(as % of GDP) of Coal in 1985 and the Mineral Rent(as % of GDP) of Oil in 2008?
Make the answer very short. 0.03. What is the difference between the Mineral Rent(as % of GDP) in Coal in 1985 and the Mineral Rent(as % of GDP) in Other Minerals in 2008?
Keep it short and to the point. 0.08. What is the difference between the Mineral Rent(as % of GDP) of Natural Gas in 1985 and the Mineral Rent(as % of GDP) of Oil in 2008?
Provide a short and direct response. 0.15. What is the difference between the Mineral Rent(as % of GDP) in Natural Gas in 1985 and the Mineral Rent(as % of GDP) in Other Minerals in 2008?
Your response must be concise. 0.2. What is the difference between the Mineral Rent(as % of GDP) in Oil in 1985 and the Mineral Rent(as % of GDP) in Other Minerals in 2008?
Give a very brief answer. 0.09. What is the difference between the Mineral Rent(as % of GDP) in Coal in 1985 and the Mineral Rent(as % of GDP) in Natural Gas in 2009?
Your answer should be very brief. 0.02. What is the difference between the Mineral Rent(as % of GDP) of Coal in 1985 and the Mineral Rent(as % of GDP) of Oil in 2009?
Your answer should be compact. 0.05. What is the difference between the Mineral Rent(as % of GDP) in Coal in 1985 and the Mineral Rent(as % of GDP) in Other Minerals in 2009?
Offer a very short reply. 0.08. What is the difference between the Mineral Rent(as % of GDP) in Natural Gas in 1985 and the Mineral Rent(as % of GDP) in Oil in 2009?
Provide a succinct answer. 0.18. What is the difference between the Mineral Rent(as % of GDP) of Natural Gas in 1985 and the Mineral Rent(as % of GDP) of Other Minerals in 2009?
Give a very brief answer. 0.2. What is the difference between the Mineral Rent(as % of GDP) in Oil in 1985 and the Mineral Rent(as % of GDP) in Other Minerals in 2009?
Your answer should be very brief. 0.09. What is the difference between the Mineral Rent(as % of GDP) in Coal in 2004 and the Mineral Rent(as % of GDP) in Natural Gas in 2005?
Give a very brief answer. -0.12. What is the difference between the Mineral Rent(as % of GDP) in Coal in 2004 and the Mineral Rent(as % of GDP) in Oil in 2005?
Your answer should be compact. -0.03. What is the difference between the Mineral Rent(as % of GDP) of Coal in 2004 and the Mineral Rent(as % of GDP) of Other Minerals in 2005?
Ensure brevity in your answer.  0.01. What is the difference between the Mineral Rent(as % of GDP) in Natural Gas in 2004 and the Mineral Rent(as % of GDP) in Oil in 2005?
Your answer should be compact. 0.05. What is the difference between the Mineral Rent(as % of GDP) of Natural Gas in 2004 and the Mineral Rent(as % of GDP) of Other Minerals in 2005?
Offer a terse response. 0.09. What is the difference between the Mineral Rent(as % of GDP) in Oil in 2004 and the Mineral Rent(as % of GDP) in Other Minerals in 2005?
Your answer should be very brief. 0.03. What is the difference between the Mineral Rent(as % of GDP) of Coal in 2004 and the Mineral Rent(as % of GDP) of Natural Gas in 2006?
Offer a very short reply. -0.12. What is the difference between the Mineral Rent(as % of GDP) in Coal in 2004 and the Mineral Rent(as % of GDP) in Oil in 2006?
Keep it short and to the point. -0.03. What is the difference between the Mineral Rent(as % of GDP) of Coal in 2004 and the Mineral Rent(as % of GDP) of Other Minerals in 2006?
Ensure brevity in your answer.  0.01. What is the difference between the Mineral Rent(as % of GDP) in Natural Gas in 2004 and the Mineral Rent(as % of GDP) in Oil in 2006?
Your response must be concise. 0.04. What is the difference between the Mineral Rent(as % of GDP) in Natural Gas in 2004 and the Mineral Rent(as % of GDP) in Other Minerals in 2006?
Your answer should be very brief. 0.09. What is the difference between the Mineral Rent(as % of GDP) of Oil in 2004 and the Mineral Rent(as % of GDP) of Other Minerals in 2006?
Provide a succinct answer. 0.03. What is the difference between the Mineral Rent(as % of GDP) in Coal in 2004 and the Mineral Rent(as % of GDP) in Natural Gas in 2007?
Your answer should be very brief. -0.1. What is the difference between the Mineral Rent(as % of GDP) in Coal in 2004 and the Mineral Rent(as % of GDP) in Oil in 2007?
Your answer should be compact. -0.03. What is the difference between the Mineral Rent(as % of GDP) of Coal in 2004 and the Mineral Rent(as % of GDP) of Other Minerals in 2007?
Give a very brief answer. 0.01. What is the difference between the Mineral Rent(as % of GDP) of Natural Gas in 2004 and the Mineral Rent(as % of GDP) of Oil in 2007?
Ensure brevity in your answer.  0.04. What is the difference between the Mineral Rent(as % of GDP) in Natural Gas in 2004 and the Mineral Rent(as % of GDP) in Other Minerals in 2007?
Your answer should be very brief. 0.09. What is the difference between the Mineral Rent(as % of GDP) of Oil in 2004 and the Mineral Rent(as % of GDP) of Other Minerals in 2007?
Offer a terse response. 0.03. What is the difference between the Mineral Rent(as % of GDP) of Coal in 2004 and the Mineral Rent(as % of GDP) of Natural Gas in 2008?
Provide a short and direct response. -0.12. What is the difference between the Mineral Rent(as % of GDP) in Coal in 2004 and the Mineral Rent(as % of GDP) in Oil in 2008?
Make the answer very short. -0.04. What is the difference between the Mineral Rent(as % of GDP) of Coal in 2004 and the Mineral Rent(as % of GDP) of Other Minerals in 2008?
Your answer should be very brief. 0.01. What is the difference between the Mineral Rent(as % of GDP) of Natural Gas in 2004 and the Mineral Rent(as % of GDP) of Oil in 2008?
Make the answer very short. 0.04. What is the difference between the Mineral Rent(as % of GDP) in Natural Gas in 2004 and the Mineral Rent(as % of GDP) in Other Minerals in 2008?
Provide a short and direct response. 0.09. What is the difference between the Mineral Rent(as % of GDP) of Oil in 2004 and the Mineral Rent(as % of GDP) of Other Minerals in 2008?
Offer a very short reply. 0.03. What is the difference between the Mineral Rent(as % of GDP) of Coal in 2004 and the Mineral Rent(as % of GDP) of Natural Gas in 2009?
Make the answer very short. -0.05. What is the difference between the Mineral Rent(as % of GDP) of Coal in 2004 and the Mineral Rent(as % of GDP) of Oil in 2009?
Your answer should be compact. -0.02. What is the difference between the Mineral Rent(as % of GDP) in Coal in 2004 and the Mineral Rent(as % of GDP) in Other Minerals in 2009?
Make the answer very short. 0.01. What is the difference between the Mineral Rent(as % of GDP) in Natural Gas in 2004 and the Mineral Rent(as % of GDP) in Oil in 2009?
Provide a short and direct response. 0.06. What is the difference between the Mineral Rent(as % of GDP) in Natural Gas in 2004 and the Mineral Rent(as % of GDP) in Other Minerals in 2009?
Provide a short and direct response. 0.09. What is the difference between the Mineral Rent(as % of GDP) of Oil in 2004 and the Mineral Rent(as % of GDP) of Other Minerals in 2009?
Provide a succinct answer. 0.03. What is the difference between the Mineral Rent(as % of GDP) in Coal in 2005 and the Mineral Rent(as % of GDP) in Natural Gas in 2006?
Your answer should be very brief. -0.13. What is the difference between the Mineral Rent(as % of GDP) in Coal in 2005 and the Mineral Rent(as % of GDP) in Oil in 2006?
Your answer should be very brief. -0.04. What is the difference between the Mineral Rent(as % of GDP) in Coal in 2005 and the Mineral Rent(as % of GDP) in Other Minerals in 2006?
Give a very brief answer. 0. What is the difference between the Mineral Rent(as % of GDP) in Natural Gas in 2005 and the Mineral Rent(as % of GDP) in Oil in 2006?
Your answer should be compact. 0.09. What is the difference between the Mineral Rent(as % of GDP) in Natural Gas in 2005 and the Mineral Rent(as % of GDP) in Other Minerals in 2006?
Ensure brevity in your answer.  0.14. What is the difference between the Mineral Rent(as % of GDP) of Oil in 2005 and the Mineral Rent(as % of GDP) of Other Minerals in 2006?
Your answer should be compact. 0.04. What is the difference between the Mineral Rent(as % of GDP) in Coal in 2005 and the Mineral Rent(as % of GDP) in Natural Gas in 2007?
Make the answer very short. -0.11. What is the difference between the Mineral Rent(as % of GDP) of Coal in 2005 and the Mineral Rent(as % of GDP) of Oil in 2007?
Your response must be concise. -0.04. What is the difference between the Mineral Rent(as % of GDP) in Coal in 2005 and the Mineral Rent(as % of GDP) in Other Minerals in 2007?
Offer a very short reply. 0. What is the difference between the Mineral Rent(as % of GDP) in Natural Gas in 2005 and the Mineral Rent(as % of GDP) in Oil in 2007?
Provide a succinct answer. 0.09. What is the difference between the Mineral Rent(as % of GDP) of Natural Gas in 2005 and the Mineral Rent(as % of GDP) of Other Minerals in 2007?
Make the answer very short. 0.14. What is the difference between the Mineral Rent(as % of GDP) in Oil in 2005 and the Mineral Rent(as % of GDP) in Other Minerals in 2007?
Keep it short and to the point. 0.04. What is the difference between the Mineral Rent(as % of GDP) of Coal in 2005 and the Mineral Rent(as % of GDP) of Natural Gas in 2008?
Ensure brevity in your answer.  -0.13. What is the difference between the Mineral Rent(as % of GDP) of Coal in 2005 and the Mineral Rent(as % of GDP) of Oil in 2008?
Make the answer very short. -0.05. What is the difference between the Mineral Rent(as % of GDP) in Coal in 2005 and the Mineral Rent(as % of GDP) in Other Minerals in 2008?
Give a very brief answer. 0. What is the difference between the Mineral Rent(as % of GDP) in Natural Gas in 2005 and the Mineral Rent(as % of GDP) in Oil in 2008?
Your answer should be compact. 0.09. What is the difference between the Mineral Rent(as % of GDP) in Natural Gas in 2005 and the Mineral Rent(as % of GDP) in Other Minerals in 2008?
Ensure brevity in your answer.  0.14. What is the difference between the Mineral Rent(as % of GDP) in Oil in 2005 and the Mineral Rent(as % of GDP) in Other Minerals in 2008?
Your answer should be very brief. 0.04. What is the difference between the Mineral Rent(as % of GDP) of Coal in 2005 and the Mineral Rent(as % of GDP) of Natural Gas in 2009?
Offer a terse response. -0.06. What is the difference between the Mineral Rent(as % of GDP) of Coal in 2005 and the Mineral Rent(as % of GDP) of Oil in 2009?
Provide a short and direct response. -0.03. What is the difference between the Mineral Rent(as % of GDP) of Coal in 2005 and the Mineral Rent(as % of GDP) of Other Minerals in 2009?
Keep it short and to the point. 0. What is the difference between the Mineral Rent(as % of GDP) in Natural Gas in 2005 and the Mineral Rent(as % of GDP) in Oil in 2009?
Make the answer very short. 0.11. What is the difference between the Mineral Rent(as % of GDP) of Natural Gas in 2005 and the Mineral Rent(as % of GDP) of Other Minerals in 2009?
Ensure brevity in your answer.  0.14. What is the difference between the Mineral Rent(as % of GDP) of Oil in 2005 and the Mineral Rent(as % of GDP) of Other Minerals in 2009?
Keep it short and to the point. 0.04. What is the difference between the Mineral Rent(as % of GDP) of Coal in 2006 and the Mineral Rent(as % of GDP) of Natural Gas in 2007?
Provide a succinct answer. -0.11. What is the difference between the Mineral Rent(as % of GDP) of Coal in 2006 and the Mineral Rent(as % of GDP) of Oil in 2007?
Your answer should be very brief. -0.04. What is the difference between the Mineral Rent(as % of GDP) of Coal in 2006 and the Mineral Rent(as % of GDP) of Other Minerals in 2007?
Keep it short and to the point. 0. What is the difference between the Mineral Rent(as % of GDP) in Natural Gas in 2006 and the Mineral Rent(as % of GDP) in Oil in 2007?
Make the answer very short. 0.09. What is the difference between the Mineral Rent(as % of GDP) of Natural Gas in 2006 and the Mineral Rent(as % of GDP) of Other Minerals in 2007?
Keep it short and to the point. 0.13. What is the difference between the Mineral Rent(as % of GDP) in Oil in 2006 and the Mineral Rent(as % of GDP) in Other Minerals in 2007?
Offer a very short reply. 0.04. What is the difference between the Mineral Rent(as % of GDP) of Coal in 2006 and the Mineral Rent(as % of GDP) of Natural Gas in 2008?
Provide a succinct answer. -0.13. What is the difference between the Mineral Rent(as % of GDP) of Coal in 2006 and the Mineral Rent(as % of GDP) of Oil in 2008?
Offer a very short reply. -0.05. What is the difference between the Mineral Rent(as % of GDP) of Coal in 2006 and the Mineral Rent(as % of GDP) of Other Minerals in 2008?
Offer a terse response. 0. What is the difference between the Mineral Rent(as % of GDP) of Natural Gas in 2006 and the Mineral Rent(as % of GDP) of Oil in 2008?
Your answer should be very brief. 0.08. What is the difference between the Mineral Rent(as % of GDP) in Natural Gas in 2006 and the Mineral Rent(as % of GDP) in Other Minerals in 2008?
Make the answer very short. 0.13. What is the difference between the Mineral Rent(as % of GDP) in Oil in 2006 and the Mineral Rent(as % of GDP) in Other Minerals in 2008?
Give a very brief answer. 0.04. What is the difference between the Mineral Rent(as % of GDP) of Coal in 2006 and the Mineral Rent(as % of GDP) of Natural Gas in 2009?
Provide a succinct answer. -0.06. What is the difference between the Mineral Rent(as % of GDP) of Coal in 2006 and the Mineral Rent(as % of GDP) of Oil in 2009?
Your answer should be compact. -0.02. What is the difference between the Mineral Rent(as % of GDP) of Coal in 2006 and the Mineral Rent(as % of GDP) of Other Minerals in 2009?
Provide a succinct answer. 0. What is the difference between the Mineral Rent(as % of GDP) in Natural Gas in 2006 and the Mineral Rent(as % of GDP) in Oil in 2009?
Provide a short and direct response. 0.1. What is the difference between the Mineral Rent(as % of GDP) in Natural Gas in 2006 and the Mineral Rent(as % of GDP) in Other Minerals in 2009?
Provide a succinct answer. 0.13. What is the difference between the Mineral Rent(as % of GDP) in Oil in 2006 and the Mineral Rent(as % of GDP) in Other Minerals in 2009?
Your response must be concise. 0.05. What is the difference between the Mineral Rent(as % of GDP) in Coal in 2007 and the Mineral Rent(as % of GDP) in Natural Gas in 2008?
Offer a very short reply. -0.12. What is the difference between the Mineral Rent(as % of GDP) of Coal in 2007 and the Mineral Rent(as % of GDP) of Oil in 2008?
Make the answer very short. -0.04. What is the difference between the Mineral Rent(as % of GDP) of Coal in 2007 and the Mineral Rent(as % of GDP) of Other Minerals in 2008?
Ensure brevity in your answer.  0.01. What is the difference between the Mineral Rent(as % of GDP) of Natural Gas in 2007 and the Mineral Rent(as % of GDP) of Oil in 2008?
Ensure brevity in your answer.  0.06. What is the difference between the Mineral Rent(as % of GDP) of Natural Gas in 2007 and the Mineral Rent(as % of GDP) of Other Minerals in 2008?
Your response must be concise. 0.11. What is the difference between the Mineral Rent(as % of GDP) of Oil in 2007 and the Mineral Rent(as % of GDP) of Other Minerals in 2008?
Give a very brief answer. 0.04. What is the difference between the Mineral Rent(as % of GDP) of Coal in 2007 and the Mineral Rent(as % of GDP) of Natural Gas in 2009?
Your answer should be very brief. -0.05. What is the difference between the Mineral Rent(as % of GDP) of Coal in 2007 and the Mineral Rent(as % of GDP) of Oil in 2009?
Make the answer very short. -0.02. What is the difference between the Mineral Rent(as % of GDP) of Coal in 2007 and the Mineral Rent(as % of GDP) of Other Minerals in 2009?
Your answer should be compact. 0.01. What is the difference between the Mineral Rent(as % of GDP) of Natural Gas in 2007 and the Mineral Rent(as % of GDP) of Oil in 2009?
Offer a very short reply. 0.08. What is the difference between the Mineral Rent(as % of GDP) of Natural Gas in 2007 and the Mineral Rent(as % of GDP) of Other Minerals in 2009?
Offer a terse response. 0.11. What is the difference between the Mineral Rent(as % of GDP) in Oil in 2007 and the Mineral Rent(as % of GDP) in Other Minerals in 2009?
Your answer should be very brief. 0.04. What is the difference between the Mineral Rent(as % of GDP) of Coal in 2008 and the Mineral Rent(as % of GDP) of Natural Gas in 2009?
Ensure brevity in your answer.  0. What is the difference between the Mineral Rent(as % of GDP) of Coal in 2008 and the Mineral Rent(as % of GDP) of Oil in 2009?
Your response must be concise. 0.04. What is the difference between the Mineral Rent(as % of GDP) of Coal in 2008 and the Mineral Rent(as % of GDP) of Other Minerals in 2009?
Give a very brief answer. 0.06. What is the difference between the Mineral Rent(as % of GDP) in Natural Gas in 2008 and the Mineral Rent(as % of GDP) in Oil in 2009?
Keep it short and to the point. 0.11. What is the difference between the Mineral Rent(as % of GDP) in Natural Gas in 2008 and the Mineral Rent(as % of GDP) in Other Minerals in 2009?
Your response must be concise. 0.13. What is the difference between the Mineral Rent(as % of GDP) in Oil in 2008 and the Mineral Rent(as % of GDP) in Other Minerals in 2009?
Your response must be concise. 0.05. What is the average Mineral Rent(as % of GDP) of Coal per year?
Ensure brevity in your answer.  0.04. What is the average Mineral Rent(as % of GDP) of Natural Gas per year?
Make the answer very short. 0.15. What is the average Mineral Rent(as % of GDP) of Oil per year?
Keep it short and to the point. 0.06. What is the average Mineral Rent(as % of GDP) in Other Minerals per year?
Provide a succinct answer. 0. In the year 1983, what is the difference between the Mineral Rent(as % of GDP) in Coal and Mineral Rent(as % of GDP) in Natural Gas?
Give a very brief answer. -0.12. In the year 1983, what is the difference between the Mineral Rent(as % of GDP) of Coal and Mineral Rent(as % of GDP) of Oil?
Offer a terse response. 0.02. In the year 1983, what is the difference between the Mineral Rent(as % of GDP) in Coal and Mineral Rent(as % of GDP) in Other Minerals?
Offer a terse response. 0.11. In the year 1983, what is the difference between the Mineral Rent(as % of GDP) in Natural Gas and Mineral Rent(as % of GDP) in Oil?
Offer a very short reply. 0.13. In the year 1983, what is the difference between the Mineral Rent(as % of GDP) in Natural Gas and Mineral Rent(as % of GDP) in Other Minerals?
Make the answer very short. 0.23. In the year 1983, what is the difference between the Mineral Rent(as % of GDP) in Oil and Mineral Rent(as % of GDP) in Other Minerals?
Give a very brief answer. 0.09. In the year 1984, what is the difference between the Mineral Rent(as % of GDP) of Coal and Mineral Rent(as % of GDP) of Natural Gas?
Your answer should be compact. -0.23. In the year 1984, what is the difference between the Mineral Rent(as % of GDP) in Coal and Mineral Rent(as % of GDP) in Oil?
Make the answer very short. -0.08. In the year 1984, what is the difference between the Mineral Rent(as % of GDP) in Coal and Mineral Rent(as % of GDP) in Other Minerals?
Ensure brevity in your answer.  0.02. In the year 1984, what is the difference between the Mineral Rent(as % of GDP) in Natural Gas and Mineral Rent(as % of GDP) in Oil?
Offer a very short reply. 0.15. In the year 1984, what is the difference between the Mineral Rent(as % of GDP) in Natural Gas and Mineral Rent(as % of GDP) in Other Minerals?
Offer a very short reply. 0.25. In the year 1984, what is the difference between the Mineral Rent(as % of GDP) in Oil and Mineral Rent(as % of GDP) in Other Minerals?
Your answer should be compact. 0.1. In the year 1985, what is the difference between the Mineral Rent(as % of GDP) in Coal and Mineral Rent(as % of GDP) in Natural Gas?
Your answer should be compact. -0.12. In the year 1985, what is the difference between the Mineral Rent(as % of GDP) of Coal and Mineral Rent(as % of GDP) of Oil?
Offer a terse response. -0.01. In the year 1985, what is the difference between the Mineral Rent(as % of GDP) in Coal and Mineral Rent(as % of GDP) in Other Minerals?
Offer a terse response. 0.08. In the year 1985, what is the difference between the Mineral Rent(as % of GDP) of Natural Gas and Mineral Rent(as % of GDP) of Oil?
Make the answer very short. 0.11. In the year 1985, what is the difference between the Mineral Rent(as % of GDP) of Natural Gas and Mineral Rent(as % of GDP) of Other Minerals?
Ensure brevity in your answer.  0.2. In the year 1985, what is the difference between the Mineral Rent(as % of GDP) of Oil and Mineral Rent(as % of GDP) of Other Minerals?
Your answer should be compact. 0.09. In the year 2004, what is the difference between the Mineral Rent(as % of GDP) of Coal and Mineral Rent(as % of GDP) of Natural Gas?
Keep it short and to the point. -0.07. In the year 2004, what is the difference between the Mineral Rent(as % of GDP) in Coal and Mineral Rent(as % of GDP) in Oil?
Ensure brevity in your answer.  -0.02. In the year 2004, what is the difference between the Mineral Rent(as % of GDP) in Coal and Mineral Rent(as % of GDP) in Other Minerals?
Offer a very short reply. 0.01. In the year 2004, what is the difference between the Mineral Rent(as % of GDP) in Natural Gas and Mineral Rent(as % of GDP) in Oil?
Ensure brevity in your answer.  0.06. In the year 2004, what is the difference between the Mineral Rent(as % of GDP) in Natural Gas and Mineral Rent(as % of GDP) in Other Minerals?
Your answer should be compact. 0.09. In the year 2004, what is the difference between the Mineral Rent(as % of GDP) in Oil and Mineral Rent(as % of GDP) in Other Minerals?
Your answer should be compact. 0.03. In the year 2005, what is the difference between the Mineral Rent(as % of GDP) in Coal and Mineral Rent(as % of GDP) in Natural Gas?
Your answer should be very brief. -0.13. In the year 2005, what is the difference between the Mineral Rent(as % of GDP) of Coal and Mineral Rent(as % of GDP) of Oil?
Make the answer very short. -0.04. In the year 2005, what is the difference between the Mineral Rent(as % of GDP) of Coal and Mineral Rent(as % of GDP) of Other Minerals?
Your answer should be very brief. 0. In the year 2005, what is the difference between the Mineral Rent(as % of GDP) in Natural Gas and Mineral Rent(as % of GDP) in Oil?
Offer a very short reply. 0.1. In the year 2005, what is the difference between the Mineral Rent(as % of GDP) of Natural Gas and Mineral Rent(as % of GDP) of Other Minerals?
Offer a very short reply. 0.14. In the year 2005, what is the difference between the Mineral Rent(as % of GDP) of Oil and Mineral Rent(as % of GDP) of Other Minerals?
Ensure brevity in your answer.  0.04. In the year 2006, what is the difference between the Mineral Rent(as % of GDP) of Coal and Mineral Rent(as % of GDP) of Natural Gas?
Offer a terse response. -0.13. In the year 2006, what is the difference between the Mineral Rent(as % of GDP) in Coal and Mineral Rent(as % of GDP) in Oil?
Offer a terse response. -0.04. In the year 2006, what is the difference between the Mineral Rent(as % of GDP) of Coal and Mineral Rent(as % of GDP) of Other Minerals?
Your response must be concise. 0. In the year 2006, what is the difference between the Mineral Rent(as % of GDP) in Natural Gas and Mineral Rent(as % of GDP) in Oil?
Offer a very short reply. 0.08. In the year 2006, what is the difference between the Mineral Rent(as % of GDP) in Natural Gas and Mineral Rent(as % of GDP) in Other Minerals?
Ensure brevity in your answer.  0.13. In the year 2006, what is the difference between the Mineral Rent(as % of GDP) of Oil and Mineral Rent(as % of GDP) of Other Minerals?
Your answer should be very brief. 0.05. In the year 2007, what is the difference between the Mineral Rent(as % of GDP) in Coal and Mineral Rent(as % of GDP) in Natural Gas?
Ensure brevity in your answer.  -0.1. In the year 2007, what is the difference between the Mineral Rent(as % of GDP) of Coal and Mineral Rent(as % of GDP) of Oil?
Make the answer very short. -0.03. In the year 2007, what is the difference between the Mineral Rent(as % of GDP) of Natural Gas and Mineral Rent(as % of GDP) of Oil?
Provide a succinct answer. 0.07. In the year 2007, what is the difference between the Mineral Rent(as % of GDP) in Natural Gas and Mineral Rent(as % of GDP) in Other Minerals?
Your answer should be very brief. 0.11. In the year 2007, what is the difference between the Mineral Rent(as % of GDP) of Oil and Mineral Rent(as % of GDP) of Other Minerals?
Keep it short and to the point. 0.04. In the year 2008, what is the difference between the Mineral Rent(as % of GDP) in Coal and Mineral Rent(as % of GDP) in Natural Gas?
Make the answer very short. -0.07. In the year 2008, what is the difference between the Mineral Rent(as % of GDP) in Coal and Mineral Rent(as % of GDP) in Oil?
Give a very brief answer. 0.01. In the year 2008, what is the difference between the Mineral Rent(as % of GDP) in Coal and Mineral Rent(as % of GDP) in Other Minerals?
Keep it short and to the point. 0.06. In the year 2008, what is the difference between the Mineral Rent(as % of GDP) in Natural Gas and Mineral Rent(as % of GDP) in Oil?
Offer a very short reply. 0.09. In the year 2008, what is the difference between the Mineral Rent(as % of GDP) in Natural Gas and Mineral Rent(as % of GDP) in Other Minerals?
Your answer should be very brief. 0.13. In the year 2008, what is the difference between the Mineral Rent(as % of GDP) of Oil and Mineral Rent(as % of GDP) of Other Minerals?
Your response must be concise. 0.05. In the year 2009, what is the difference between the Mineral Rent(as % of GDP) of Coal and Mineral Rent(as % of GDP) of Natural Gas?
Make the answer very short. -0.05. In the year 2009, what is the difference between the Mineral Rent(as % of GDP) of Coal and Mineral Rent(as % of GDP) of Oil?
Give a very brief answer. -0.02. In the year 2009, what is the difference between the Mineral Rent(as % of GDP) in Coal and Mineral Rent(as % of GDP) in Other Minerals?
Keep it short and to the point. 0.01. In the year 2009, what is the difference between the Mineral Rent(as % of GDP) of Natural Gas and Mineral Rent(as % of GDP) of Oil?
Your response must be concise. 0.03. In the year 2009, what is the difference between the Mineral Rent(as % of GDP) of Natural Gas and Mineral Rent(as % of GDP) of Other Minerals?
Your answer should be compact. 0.06. In the year 2009, what is the difference between the Mineral Rent(as % of GDP) of Oil and Mineral Rent(as % of GDP) of Other Minerals?
Ensure brevity in your answer.  0.03. What is the ratio of the Mineral Rent(as % of GDP) in Coal in 1983 to that in 1984?
Ensure brevity in your answer.  6.93. What is the ratio of the Mineral Rent(as % of GDP) of Natural Gas in 1983 to that in 1984?
Your answer should be compact. 0.94. What is the ratio of the Mineral Rent(as % of GDP) of Other Minerals in 1983 to that in 1984?
Ensure brevity in your answer.  5.03. What is the ratio of the Mineral Rent(as % of GDP) in Coal in 1983 to that in 1985?
Keep it short and to the point. 1.4. What is the ratio of the Mineral Rent(as % of GDP) of Natural Gas in 1983 to that in 1985?
Give a very brief answer. 1.14. What is the ratio of the Mineral Rent(as % of GDP) of Oil in 1983 to that in 1985?
Offer a terse response. 1.08. What is the ratio of the Mineral Rent(as % of GDP) of Other Minerals in 1983 to that in 1985?
Your answer should be very brief. 5.22. What is the ratio of the Mineral Rent(as % of GDP) in Coal in 1983 to that in 2004?
Make the answer very short. 9.03. What is the ratio of the Mineral Rent(as % of GDP) in Natural Gas in 1983 to that in 2004?
Give a very brief answer. 2.67. What is the ratio of the Mineral Rent(as % of GDP) of Oil in 1983 to that in 2004?
Your answer should be very brief. 3.58. What is the ratio of the Mineral Rent(as % of GDP) of Other Minerals in 1983 to that in 2004?
Ensure brevity in your answer.  145.25. What is the ratio of the Mineral Rent(as % of GDP) of Coal in 1983 to that in 2005?
Provide a short and direct response. 39.16. What is the ratio of the Mineral Rent(as % of GDP) in Natural Gas in 1983 to that in 2005?
Your answer should be very brief. 1.71. What is the ratio of the Mineral Rent(as % of GDP) of Oil in 1983 to that in 2005?
Offer a terse response. 2.46. What is the ratio of the Mineral Rent(as % of GDP) in Other Minerals in 1983 to that in 2005?
Give a very brief answer. 18.72. What is the ratio of the Mineral Rent(as % of GDP) in Coal in 1983 to that in 2006?
Make the answer very short. 30.29. What is the ratio of the Mineral Rent(as % of GDP) of Natural Gas in 1983 to that in 2006?
Keep it short and to the point. 1.8. What is the ratio of the Mineral Rent(as % of GDP) in Oil in 1983 to that in 2006?
Offer a terse response. 2.19. What is the ratio of the Mineral Rent(as % of GDP) in Other Minerals in 1983 to that in 2006?
Provide a succinct answer. 15.18. What is the ratio of the Mineral Rent(as % of GDP) of Coal in 1983 to that in 2007?
Provide a succinct answer. 10.53. What is the ratio of the Mineral Rent(as % of GDP) in Natural Gas in 1983 to that in 2007?
Ensure brevity in your answer.  2.09. What is the ratio of the Mineral Rent(as % of GDP) in Oil in 1983 to that in 2007?
Provide a succinct answer. 2.29. What is the ratio of the Mineral Rent(as % of GDP) of Other Minerals in 1983 to that in 2007?
Offer a very short reply. 6.33. What is the ratio of the Mineral Rent(as % of GDP) in Coal in 1983 to that in 2008?
Offer a terse response. 1.82. What is the ratio of the Mineral Rent(as % of GDP) in Natural Gas in 1983 to that in 2008?
Ensure brevity in your answer.  1.73. What is the ratio of the Mineral Rent(as % of GDP) in Oil in 1983 to that in 2008?
Provide a succinct answer. 2.02. What is the ratio of the Mineral Rent(as % of GDP) of Other Minerals in 1983 to that in 2008?
Offer a very short reply. 4.68. What is the ratio of the Mineral Rent(as % of GDP) of Coal in 1983 to that in 2009?
Provide a succinct answer. 15.61. What is the ratio of the Mineral Rent(as % of GDP) of Natural Gas in 1983 to that in 2009?
Keep it short and to the point. 3.82. What is the ratio of the Mineral Rent(as % of GDP) of Oil in 1983 to that in 2009?
Ensure brevity in your answer.  3.56. What is the ratio of the Mineral Rent(as % of GDP) of Other Minerals in 1983 to that in 2009?
Provide a succinct answer. 15.69. What is the ratio of the Mineral Rent(as % of GDP) in Coal in 1984 to that in 1985?
Make the answer very short. 0.2. What is the ratio of the Mineral Rent(as % of GDP) in Natural Gas in 1984 to that in 1985?
Your response must be concise. 1.22. What is the ratio of the Mineral Rent(as % of GDP) in Oil in 1984 to that in 1985?
Offer a terse response. 1.08. What is the ratio of the Mineral Rent(as % of GDP) of Other Minerals in 1984 to that in 1985?
Make the answer very short. 1.04. What is the ratio of the Mineral Rent(as % of GDP) in Coal in 1984 to that in 2004?
Your response must be concise. 1.3. What is the ratio of the Mineral Rent(as % of GDP) in Natural Gas in 1984 to that in 2004?
Offer a very short reply. 2.85. What is the ratio of the Mineral Rent(as % of GDP) of Oil in 1984 to that in 2004?
Keep it short and to the point. 3.58. What is the ratio of the Mineral Rent(as % of GDP) in Other Minerals in 1984 to that in 2004?
Offer a terse response. 28.86. What is the ratio of the Mineral Rent(as % of GDP) of Coal in 1984 to that in 2005?
Provide a succinct answer. 5.65. What is the ratio of the Mineral Rent(as % of GDP) in Natural Gas in 1984 to that in 2005?
Offer a terse response. 1.83. What is the ratio of the Mineral Rent(as % of GDP) of Oil in 1984 to that in 2005?
Your answer should be very brief. 2.46. What is the ratio of the Mineral Rent(as % of GDP) of Other Minerals in 1984 to that in 2005?
Make the answer very short. 3.72. What is the ratio of the Mineral Rent(as % of GDP) of Coal in 1984 to that in 2006?
Offer a very short reply. 4.37. What is the ratio of the Mineral Rent(as % of GDP) of Natural Gas in 1984 to that in 2006?
Ensure brevity in your answer.  1.92. What is the ratio of the Mineral Rent(as % of GDP) in Oil in 1984 to that in 2006?
Ensure brevity in your answer.  2.19. What is the ratio of the Mineral Rent(as % of GDP) of Other Minerals in 1984 to that in 2006?
Ensure brevity in your answer.  3.02. What is the ratio of the Mineral Rent(as % of GDP) in Coal in 1984 to that in 2007?
Give a very brief answer. 1.52. What is the ratio of the Mineral Rent(as % of GDP) of Natural Gas in 1984 to that in 2007?
Provide a succinct answer. 2.24. What is the ratio of the Mineral Rent(as % of GDP) in Oil in 1984 to that in 2007?
Make the answer very short. 2.29. What is the ratio of the Mineral Rent(as % of GDP) in Other Minerals in 1984 to that in 2007?
Make the answer very short. 1.26. What is the ratio of the Mineral Rent(as % of GDP) in Coal in 1984 to that in 2008?
Your answer should be compact. 0.26. What is the ratio of the Mineral Rent(as % of GDP) of Natural Gas in 1984 to that in 2008?
Make the answer very short. 1.85. What is the ratio of the Mineral Rent(as % of GDP) of Oil in 1984 to that in 2008?
Your response must be concise. 2.02. What is the ratio of the Mineral Rent(as % of GDP) in Other Minerals in 1984 to that in 2008?
Give a very brief answer. 0.93. What is the ratio of the Mineral Rent(as % of GDP) of Coal in 1984 to that in 2009?
Your answer should be very brief. 2.25. What is the ratio of the Mineral Rent(as % of GDP) in Natural Gas in 1984 to that in 2009?
Your response must be concise. 4.08. What is the ratio of the Mineral Rent(as % of GDP) of Oil in 1984 to that in 2009?
Provide a succinct answer. 3.56. What is the ratio of the Mineral Rent(as % of GDP) in Other Minerals in 1984 to that in 2009?
Offer a very short reply. 3.12. What is the ratio of the Mineral Rent(as % of GDP) in Coal in 1985 to that in 2004?
Provide a short and direct response. 6.45. What is the ratio of the Mineral Rent(as % of GDP) in Natural Gas in 1985 to that in 2004?
Keep it short and to the point. 2.34. What is the ratio of the Mineral Rent(as % of GDP) of Oil in 1985 to that in 2004?
Ensure brevity in your answer.  3.3. What is the ratio of the Mineral Rent(as % of GDP) of Other Minerals in 1985 to that in 2004?
Your answer should be compact. 27.81. What is the ratio of the Mineral Rent(as % of GDP) of Coal in 1985 to that in 2005?
Your answer should be very brief. 27.99. What is the ratio of the Mineral Rent(as % of GDP) in Natural Gas in 1985 to that in 2005?
Offer a very short reply. 1.5. What is the ratio of the Mineral Rent(as % of GDP) in Oil in 1985 to that in 2005?
Keep it short and to the point. 2.27. What is the ratio of the Mineral Rent(as % of GDP) of Other Minerals in 1985 to that in 2005?
Your response must be concise. 3.58. What is the ratio of the Mineral Rent(as % of GDP) of Coal in 1985 to that in 2006?
Make the answer very short. 21.65. What is the ratio of the Mineral Rent(as % of GDP) in Natural Gas in 1985 to that in 2006?
Keep it short and to the point. 1.57. What is the ratio of the Mineral Rent(as % of GDP) of Oil in 1985 to that in 2006?
Offer a terse response. 2.02. What is the ratio of the Mineral Rent(as % of GDP) in Other Minerals in 1985 to that in 2006?
Your answer should be compact. 2.91. What is the ratio of the Mineral Rent(as % of GDP) in Coal in 1985 to that in 2007?
Provide a succinct answer. 7.53. What is the ratio of the Mineral Rent(as % of GDP) in Natural Gas in 1985 to that in 2007?
Your answer should be very brief. 1.83. What is the ratio of the Mineral Rent(as % of GDP) in Oil in 1985 to that in 2007?
Give a very brief answer. 2.12. What is the ratio of the Mineral Rent(as % of GDP) of Other Minerals in 1985 to that in 2007?
Provide a short and direct response. 1.21. What is the ratio of the Mineral Rent(as % of GDP) in Coal in 1985 to that in 2008?
Provide a succinct answer. 1.3. What is the ratio of the Mineral Rent(as % of GDP) in Natural Gas in 1985 to that in 2008?
Give a very brief answer. 1.52. What is the ratio of the Mineral Rent(as % of GDP) in Oil in 1985 to that in 2008?
Your response must be concise. 1.86. What is the ratio of the Mineral Rent(as % of GDP) of Other Minerals in 1985 to that in 2008?
Make the answer very short. 0.9. What is the ratio of the Mineral Rent(as % of GDP) in Coal in 1985 to that in 2009?
Provide a short and direct response. 11.15. What is the ratio of the Mineral Rent(as % of GDP) of Natural Gas in 1985 to that in 2009?
Provide a short and direct response. 3.34. What is the ratio of the Mineral Rent(as % of GDP) of Oil in 1985 to that in 2009?
Offer a very short reply. 3.29. What is the ratio of the Mineral Rent(as % of GDP) of Other Minerals in 1985 to that in 2009?
Make the answer very short. 3. What is the ratio of the Mineral Rent(as % of GDP) of Coal in 2004 to that in 2005?
Make the answer very short. 4.34. What is the ratio of the Mineral Rent(as % of GDP) of Natural Gas in 2004 to that in 2005?
Keep it short and to the point. 0.64. What is the ratio of the Mineral Rent(as % of GDP) of Oil in 2004 to that in 2005?
Offer a very short reply. 0.69. What is the ratio of the Mineral Rent(as % of GDP) of Other Minerals in 2004 to that in 2005?
Give a very brief answer. 0.13. What is the ratio of the Mineral Rent(as % of GDP) in Coal in 2004 to that in 2006?
Make the answer very short. 3.35. What is the ratio of the Mineral Rent(as % of GDP) in Natural Gas in 2004 to that in 2006?
Offer a very short reply. 0.67. What is the ratio of the Mineral Rent(as % of GDP) of Oil in 2004 to that in 2006?
Your answer should be compact. 0.61. What is the ratio of the Mineral Rent(as % of GDP) in Other Minerals in 2004 to that in 2006?
Offer a terse response. 0.1. What is the ratio of the Mineral Rent(as % of GDP) in Coal in 2004 to that in 2007?
Provide a short and direct response. 1.17. What is the ratio of the Mineral Rent(as % of GDP) in Natural Gas in 2004 to that in 2007?
Offer a terse response. 0.78. What is the ratio of the Mineral Rent(as % of GDP) of Oil in 2004 to that in 2007?
Give a very brief answer. 0.64. What is the ratio of the Mineral Rent(as % of GDP) in Other Minerals in 2004 to that in 2007?
Your answer should be very brief. 0.04. What is the ratio of the Mineral Rent(as % of GDP) in Coal in 2004 to that in 2008?
Give a very brief answer. 0.2. What is the ratio of the Mineral Rent(as % of GDP) in Natural Gas in 2004 to that in 2008?
Your answer should be very brief. 0.65. What is the ratio of the Mineral Rent(as % of GDP) of Oil in 2004 to that in 2008?
Your response must be concise. 0.56. What is the ratio of the Mineral Rent(as % of GDP) in Other Minerals in 2004 to that in 2008?
Offer a terse response. 0.03. What is the ratio of the Mineral Rent(as % of GDP) in Coal in 2004 to that in 2009?
Your answer should be compact. 1.73. What is the ratio of the Mineral Rent(as % of GDP) in Natural Gas in 2004 to that in 2009?
Keep it short and to the point. 1.43. What is the ratio of the Mineral Rent(as % of GDP) in Oil in 2004 to that in 2009?
Give a very brief answer. 1. What is the ratio of the Mineral Rent(as % of GDP) of Other Minerals in 2004 to that in 2009?
Provide a short and direct response. 0.11. What is the ratio of the Mineral Rent(as % of GDP) of Coal in 2005 to that in 2006?
Provide a short and direct response. 0.77. What is the ratio of the Mineral Rent(as % of GDP) of Natural Gas in 2005 to that in 2006?
Make the answer very short. 1.05. What is the ratio of the Mineral Rent(as % of GDP) in Oil in 2005 to that in 2006?
Make the answer very short. 0.89. What is the ratio of the Mineral Rent(as % of GDP) of Other Minerals in 2005 to that in 2006?
Give a very brief answer. 0.81. What is the ratio of the Mineral Rent(as % of GDP) of Coal in 2005 to that in 2007?
Ensure brevity in your answer.  0.27. What is the ratio of the Mineral Rent(as % of GDP) in Natural Gas in 2005 to that in 2007?
Provide a short and direct response. 1.22. What is the ratio of the Mineral Rent(as % of GDP) in Oil in 2005 to that in 2007?
Make the answer very short. 0.93. What is the ratio of the Mineral Rent(as % of GDP) of Other Minerals in 2005 to that in 2007?
Give a very brief answer. 0.34. What is the ratio of the Mineral Rent(as % of GDP) in Coal in 2005 to that in 2008?
Your response must be concise. 0.05. What is the ratio of the Mineral Rent(as % of GDP) of Natural Gas in 2005 to that in 2008?
Make the answer very short. 1.01. What is the ratio of the Mineral Rent(as % of GDP) of Oil in 2005 to that in 2008?
Ensure brevity in your answer.  0.82. What is the ratio of the Mineral Rent(as % of GDP) in Other Minerals in 2005 to that in 2008?
Make the answer very short. 0.25. What is the ratio of the Mineral Rent(as % of GDP) in Coal in 2005 to that in 2009?
Ensure brevity in your answer.  0.4. What is the ratio of the Mineral Rent(as % of GDP) of Natural Gas in 2005 to that in 2009?
Keep it short and to the point. 2.23. What is the ratio of the Mineral Rent(as % of GDP) of Oil in 2005 to that in 2009?
Your answer should be very brief. 1.45. What is the ratio of the Mineral Rent(as % of GDP) of Other Minerals in 2005 to that in 2009?
Your response must be concise. 0.84. What is the ratio of the Mineral Rent(as % of GDP) in Coal in 2006 to that in 2007?
Provide a short and direct response. 0.35. What is the ratio of the Mineral Rent(as % of GDP) of Natural Gas in 2006 to that in 2007?
Provide a succinct answer. 1.16. What is the ratio of the Mineral Rent(as % of GDP) in Oil in 2006 to that in 2007?
Offer a terse response. 1.05. What is the ratio of the Mineral Rent(as % of GDP) of Other Minerals in 2006 to that in 2007?
Make the answer very short. 0.42. What is the ratio of the Mineral Rent(as % of GDP) in Coal in 2006 to that in 2008?
Offer a terse response. 0.06. What is the ratio of the Mineral Rent(as % of GDP) in Natural Gas in 2006 to that in 2008?
Offer a very short reply. 0.97. What is the ratio of the Mineral Rent(as % of GDP) in Oil in 2006 to that in 2008?
Make the answer very short. 0.92. What is the ratio of the Mineral Rent(as % of GDP) in Other Minerals in 2006 to that in 2008?
Your answer should be very brief. 0.31. What is the ratio of the Mineral Rent(as % of GDP) of Coal in 2006 to that in 2009?
Your answer should be very brief. 0.52. What is the ratio of the Mineral Rent(as % of GDP) in Natural Gas in 2006 to that in 2009?
Ensure brevity in your answer.  2.12. What is the ratio of the Mineral Rent(as % of GDP) in Oil in 2006 to that in 2009?
Your answer should be compact. 1.63. What is the ratio of the Mineral Rent(as % of GDP) of Other Minerals in 2006 to that in 2009?
Ensure brevity in your answer.  1.03. What is the ratio of the Mineral Rent(as % of GDP) in Coal in 2007 to that in 2008?
Your answer should be compact. 0.17. What is the ratio of the Mineral Rent(as % of GDP) in Natural Gas in 2007 to that in 2008?
Offer a terse response. 0.83. What is the ratio of the Mineral Rent(as % of GDP) of Oil in 2007 to that in 2008?
Offer a terse response. 0.88. What is the ratio of the Mineral Rent(as % of GDP) of Other Minerals in 2007 to that in 2008?
Offer a very short reply. 0.74. What is the ratio of the Mineral Rent(as % of GDP) of Coal in 2007 to that in 2009?
Give a very brief answer. 1.48. What is the ratio of the Mineral Rent(as % of GDP) of Natural Gas in 2007 to that in 2009?
Offer a very short reply. 1.83. What is the ratio of the Mineral Rent(as % of GDP) of Oil in 2007 to that in 2009?
Your answer should be compact. 1.55. What is the ratio of the Mineral Rent(as % of GDP) in Other Minerals in 2007 to that in 2009?
Your answer should be very brief. 2.48. What is the ratio of the Mineral Rent(as % of GDP) in Coal in 2008 to that in 2009?
Ensure brevity in your answer.  8.58. What is the ratio of the Mineral Rent(as % of GDP) of Natural Gas in 2008 to that in 2009?
Your answer should be very brief. 2.2. What is the ratio of the Mineral Rent(as % of GDP) of Oil in 2008 to that in 2009?
Provide a succinct answer. 1.77. What is the ratio of the Mineral Rent(as % of GDP) of Other Minerals in 2008 to that in 2009?
Offer a terse response. 3.35. What is the difference between the highest and the second highest Mineral Rent(as % of GDP) in Coal?
Provide a succinct answer. 0.03. What is the difference between the highest and the second highest Mineral Rent(as % of GDP) in Natural Gas?
Offer a terse response. 0.02. What is the difference between the highest and the second highest Mineral Rent(as % of GDP) of Other Minerals?
Your answer should be very brief. 0.01. What is the difference between the highest and the lowest Mineral Rent(as % of GDP) in Coal?
Ensure brevity in your answer.  0.11. What is the difference between the highest and the lowest Mineral Rent(as % of GDP) in Natural Gas?
Your answer should be compact. 0.19. What is the difference between the highest and the lowest Mineral Rent(as % of GDP) of Oil?
Offer a very short reply. 0.07. What is the difference between the highest and the lowest Mineral Rent(as % of GDP) in Other Minerals?
Provide a short and direct response. 0.01. 